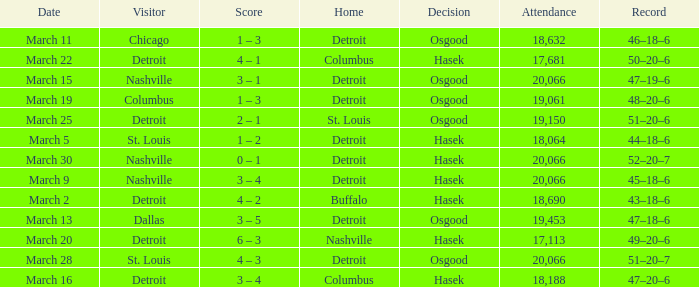Parse the table in full. {'header': ['Date', 'Visitor', 'Score', 'Home', 'Decision', 'Attendance', 'Record'], 'rows': [['March 11', 'Chicago', '1 – 3', 'Detroit', 'Osgood', '18,632', '46–18–6'], ['March 22', 'Detroit', '4 – 1', 'Columbus', 'Hasek', '17,681', '50–20–6'], ['March 15', 'Nashville', '3 – 1', 'Detroit', 'Osgood', '20,066', '47–19–6'], ['March 19', 'Columbus', '1 – 3', 'Detroit', 'Osgood', '19,061', '48–20–6'], ['March 25', 'Detroit', '2 – 1', 'St. Louis', 'Osgood', '19,150', '51–20–6'], ['March 5', 'St. Louis', '1 – 2', 'Detroit', 'Hasek', '18,064', '44–18–6'], ['March 30', 'Nashville', '0 – 1', 'Detroit', 'Hasek', '20,066', '52–20–7'], ['March 9', 'Nashville', '3 – 4', 'Detroit', 'Hasek', '20,066', '45–18–6'], ['March 2', 'Detroit', '4 – 2', 'Buffalo', 'Hasek', '18,690', '43–18–6'], ['March 13', 'Dallas', '3 – 5', 'Detroit', 'Osgood', '19,453', '47–18–6'], ['March 20', 'Detroit', '6 – 3', 'Nashville', 'Hasek', '17,113', '49–20–6'], ['March 28', 'St. Louis', '4 – 3', 'Detroit', 'Osgood', '20,066', '51–20–7'], ['March 16', 'Detroit', '3 – 4', 'Columbus', 'Hasek', '18,188', '47–20–6']]} What was the decision of the Red Wings game when they had a record of 45–18–6? Hasek. 